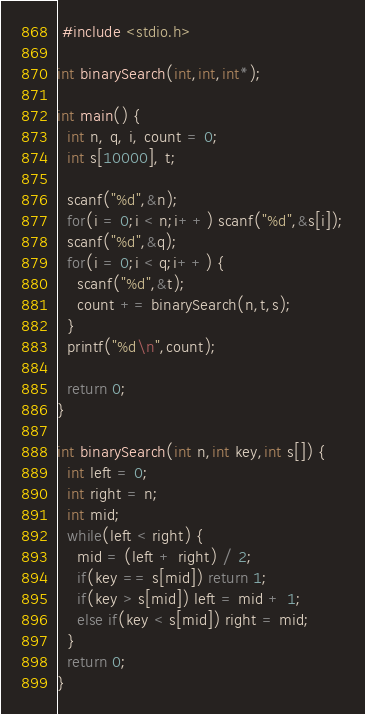Convert code to text. <code><loc_0><loc_0><loc_500><loc_500><_C_> #include <stdio.h>

int binarySearch(int,int,int*);

int main() {
  int n, q, i, count = 0; 
  int s[10000], t;
  
  scanf("%d",&n);
  for(i = 0;i < n;i++) scanf("%d",&s[i]);
  scanf("%d",&q);
  for(i = 0;i < q;i++) {
    scanf("%d",&t);
    count += binarySearch(n,t,s);
  }
  printf("%d\n",count);
  
  return 0;
}

int binarySearch(int n,int key,int s[]) {
  int left = 0;
  int right = n;
  int mid;
  while(left < right) {
    mid = (left + right) / 2;
    if(key == s[mid]) return 1;
    if(key > s[mid]) left = mid + 1;
    else if(key < s[mid]) right = mid;
  }
  return 0;
}</code> 